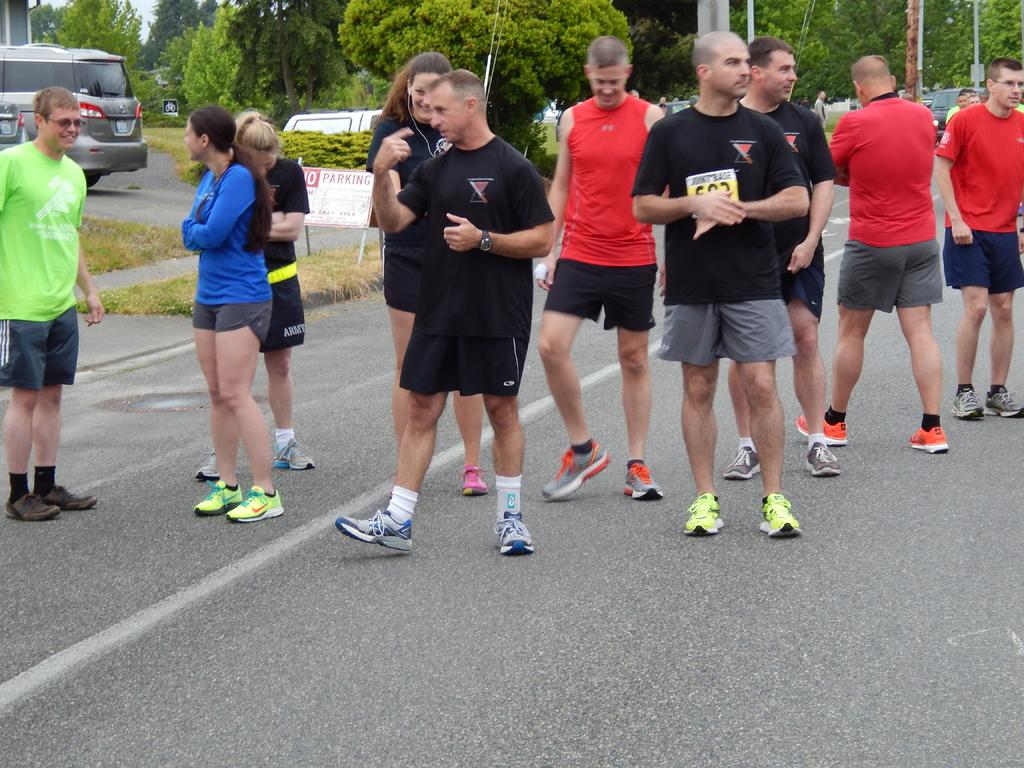What are the people in the image doing? The group of people is standing on the road. What can be seen in the background of the image? There are trees, vehicles, grass, poles, and other objects visible in the background. Can you describe the natural elements in the background of the image? The natural elements in the background include trees and grass. What type of ship can be seen sailing in the background of the image? There is no ship present in the image; it features a group of people standing on the road with various background elements. How quiet is the scene in the image? The image does not provide any information about the noise level or the presence of sound, so it cannot be determined from the image. 